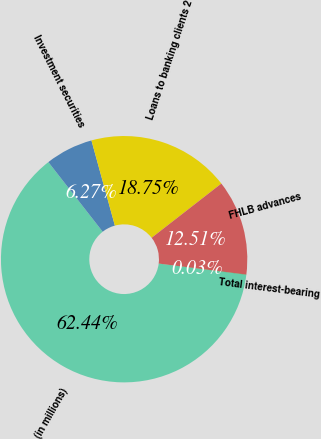Convert chart. <chart><loc_0><loc_0><loc_500><loc_500><pie_chart><fcel>(in millions)<fcel>Investment securities<fcel>Loans to banking clients 2<fcel>FHLB advances<fcel>Total interest-bearing<nl><fcel>62.43%<fcel>6.27%<fcel>18.75%<fcel>12.51%<fcel>0.03%<nl></chart> 